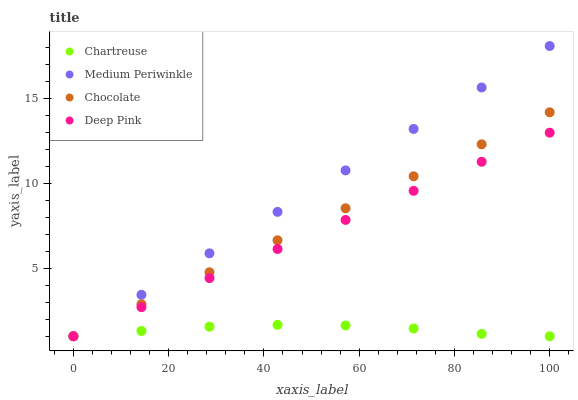Does Chartreuse have the minimum area under the curve?
Answer yes or no. Yes. Does Medium Periwinkle have the maximum area under the curve?
Answer yes or no. Yes. Does Deep Pink have the minimum area under the curve?
Answer yes or no. No. Does Deep Pink have the maximum area under the curve?
Answer yes or no. No. Is Deep Pink the smoothest?
Answer yes or no. Yes. Is Chartreuse the roughest?
Answer yes or no. Yes. Is Medium Periwinkle the smoothest?
Answer yes or no. No. Is Medium Periwinkle the roughest?
Answer yes or no. No. Does Chartreuse have the lowest value?
Answer yes or no. Yes. Does Medium Periwinkle have the highest value?
Answer yes or no. Yes. Does Deep Pink have the highest value?
Answer yes or no. No. Does Deep Pink intersect Chartreuse?
Answer yes or no. Yes. Is Deep Pink less than Chartreuse?
Answer yes or no. No. Is Deep Pink greater than Chartreuse?
Answer yes or no. No. 